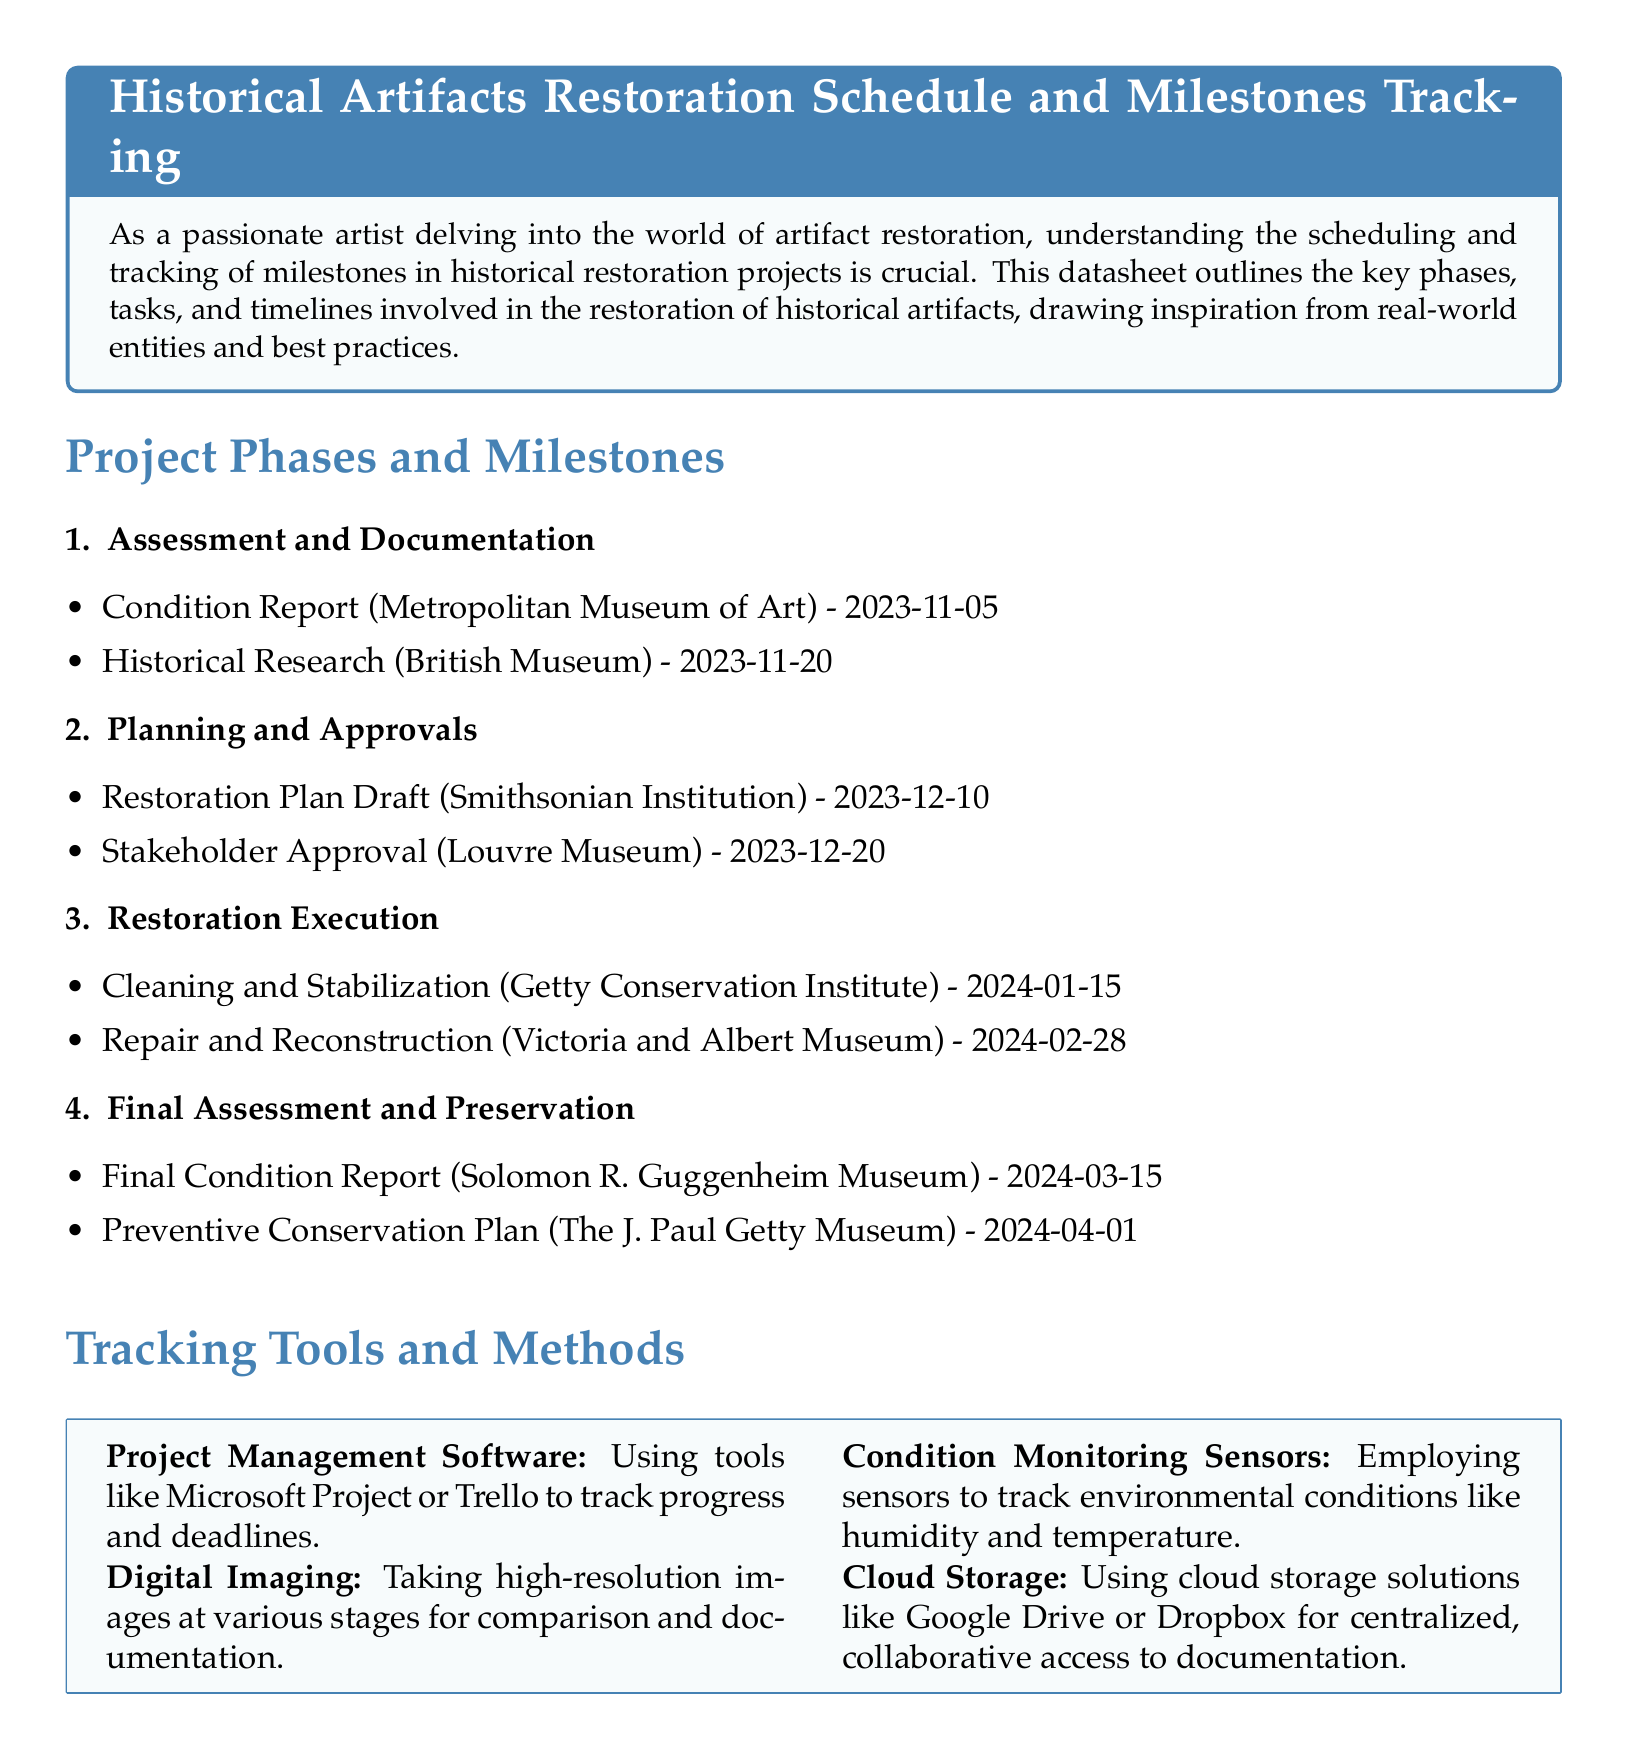What is the date of the Condition Report? The Condition Report is scheduled for 2023-11-05, as shown in the Assessment and Documentation phase.
Answer: 2023-11-05 Who is responsible for the Final Condition Report? The Final Condition Report is noted to be handled by the Solomon R. Guggenheim Museum in the Final Assessment and Preservation phase.
Answer: Solomon R. Guggenheim Museum What is the last milestone mentioned in the document? The last milestone detailed is the Preventive Conservation Plan, with a due date of 2024-04-01 mentioned in the Final Assessment and Preservation phase.
Answer: Preventive Conservation Plan Which institution's approval is needed by December 20, 2023? The document mentions that stakeholder approval needs to be secured from the Louvre Museum by this date in the Planning and Approvals phase.
Answer: Louvre Museum How many milestones are listed under the Restoration Execution phase? The document provides information on two milestones: Cleaning and Stabilization, and Repair and Reconstruction under the Restoration Execution phase.
Answer: 2 What tracking tool is recommended for condition monitoring? The document specifies using sensors for monitoring environmental conditions like humidity and temperature under the Tracking Tools and Methods section.
Answer: Condition Monitoring Sensors What is the role of Microsoft Project as mentioned in the document? The document states that Microsoft Project is proposed as a project management software tool to track progress and deadlines in the Tracking Tools and Methods section.
Answer: Project Management Software When is the final preservation milestone scheduled? The Preventive Conservation Plan is the last milestone, scheduled for 2024-04-01, as indicated in the Final Assessment and Preservation phase.
Answer: 2024-04-01 